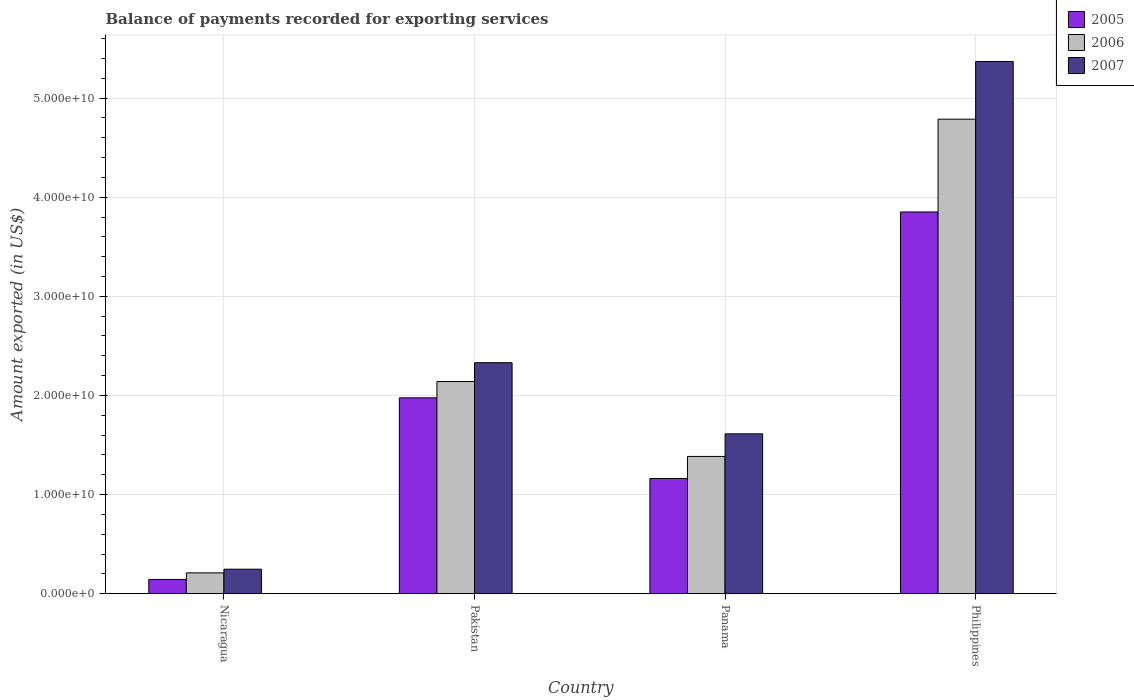Are the number of bars per tick equal to the number of legend labels?
Give a very brief answer. Yes. Are the number of bars on each tick of the X-axis equal?
Offer a very short reply. Yes. How many bars are there on the 2nd tick from the left?
Your answer should be compact. 3. How many bars are there on the 4th tick from the right?
Offer a terse response. 3. What is the label of the 2nd group of bars from the left?
Your answer should be compact. Pakistan. In how many cases, is the number of bars for a given country not equal to the number of legend labels?
Your answer should be very brief. 0. What is the amount exported in 2006 in Panama?
Provide a short and direct response. 1.38e+1. Across all countries, what is the maximum amount exported in 2007?
Keep it short and to the point. 5.37e+1. Across all countries, what is the minimum amount exported in 2007?
Provide a succinct answer. 2.47e+09. In which country was the amount exported in 2005 maximum?
Keep it short and to the point. Philippines. In which country was the amount exported in 2007 minimum?
Offer a very short reply. Nicaragua. What is the total amount exported in 2007 in the graph?
Your answer should be compact. 9.56e+1. What is the difference between the amount exported in 2005 in Nicaragua and that in Philippines?
Ensure brevity in your answer.  -3.71e+1. What is the difference between the amount exported in 2005 in Nicaragua and the amount exported in 2007 in Pakistan?
Your answer should be very brief. -2.19e+1. What is the average amount exported in 2007 per country?
Offer a very short reply. 2.39e+1. What is the difference between the amount exported of/in 2007 and amount exported of/in 2006 in Philippines?
Offer a terse response. 5.82e+09. What is the ratio of the amount exported in 2006 in Nicaragua to that in Pakistan?
Keep it short and to the point. 0.1. Is the amount exported in 2007 in Nicaragua less than that in Pakistan?
Provide a succinct answer. Yes. Is the difference between the amount exported in 2007 in Nicaragua and Philippines greater than the difference between the amount exported in 2006 in Nicaragua and Philippines?
Provide a short and direct response. No. What is the difference between the highest and the second highest amount exported in 2005?
Offer a very short reply. 1.88e+1. What is the difference between the highest and the lowest amount exported in 2005?
Give a very brief answer. 3.71e+1. What does the 2nd bar from the right in Panama represents?
Give a very brief answer. 2006. Is it the case that in every country, the sum of the amount exported in 2006 and amount exported in 2005 is greater than the amount exported in 2007?
Your answer should be very brief. Yes. Does the graph contain grids?
Your answer should be very brief. Yes. Where does the legend appear in the graph?
Your response must be concise. Top right. What is the title of the graph?
Make the answer very short. Balance of payments recorded for exporting services. Does "1975" appear as one of the legend labels in the graph?
Provide a short and direct response. No. What is the label or title of the X-axis?
Your response must be concise. Country. What is the label or title of the Y-axis?
Give a very brief answer. Amount exported (in US$). What is the Amount exported (in US$) of 2005 in Nicaragua?
Make the answer very short. 1.43e+09. What is the Amount exported (in US$) of 2006 in Nicaragua?
Keep it short and to the point. 2.10e+09. What is the Amount exported (in US$) in 2007 in Nicaragua?
Your response must be concise. 2.47e+09. What is the Amount exported (in US$) in 2005 in Pakistan?
Offer a terse response. 1.98e+1. What is the Amount exported (in US$) in 2006 in Pakistan?
Your answer should be very brief. 2.14e+1. What is the Amount exported (in US$) of 2007 in Pakistan?
Your answer should be compact. 2.33e+1. What is the Amount exported (in US$) of 2005 in Panama?
Your answer should be compact. 1.16e+1. What is the Amount exported (in US$) of 2006 in Panama?
Give a very brief answer. 1.38e+1. What is the Amount exported (in US$) in 2007 in Panama?
Your answer should be compact. 1.61e+1. What is the Amount exported (in US$) of 2005 in Philippines?
Keep it short and to the point. 3.85e+1. What is the Amount exported (in US$) in 2006 in Philippines?
Offer a very short reply. 4.79e+1. What is the Amount exported (in US$) of 2007 in Philippines?
Offer a very short reply. 5.37e+1. Across all countries, what is the maximum Amount exported (in US$) of 2005?
Provide a short and direct response. 3.85e+1. Across all countries, what is the maximum Amount exported (in US$) of 2006?
Provide a succinct answer. 4.79e+1. Across all countries, what is the maximum Amount exported (in US$) of 2007?
Offer a very short reply. 5.37e+1. Across all countries, what is the minimum Amount exported (in US$) in 2005?
Offer a terse response. 1.43e+09. Across all countries, what is the minimum Amount exported (in US$) in 2006?
Your response must be concise. 2.10e+09. Across all countries, what is the minimum Amount exported (in US$) of 2007?
Your answer should be very brief. 2.47e+09. What is the total Amount exported (in US$) in 2005 in the graph?
Keep it short and to the point. 7.13e+1. What is the total Amount exported (in US$) in 2006 in the graph?
Provide a short and direct response. 8.52e+1. What is the total Amount exported (in US$) of 2007 in the graph?
Your answer should be compact. 9.56e+1. What is the difference between the Amount exported (in US$) of 2005 in Nicaragua and that in Pakistan?
Make the answer very short. -1.83e+1. What is the difference between the Amount exported (in US$) in 2006 in Nicaragua and that in Pakistan?
Your response must be concise. -1.93e+1. What is the difference between the Amount exported (in US$) of 2007 in Nicaragua and that in Pakistan?
Keep it short and to the point. -2.08e+1. What is the difference between the Amount exported (in US$) in 2005 in Nicaragua and that in Panama?
Give a very brief answer. -1.02e+1. What is the difference between the Amount exported (in US$) in 2006 in Nicaragua and that in Panama?
Your response must be concise. -1.17e+1. What is the difference between the Amount exported (in US$) of 2007 in Nicaragua and that in Panama?
Your answer should be compact. -1.37e+1. What is the difference between the Amount exported (in US$) of 2005 in Nicaragua and that in Philippines?
Make the answer very short. -3.71e+1. What is the difference between the Amount exported (in US$) of 2006 in Nicaragua and that in Philippines?
Make the answer very short. -4.58e+1. What is the difference between the Amount exported (in US$) of 2007 in Nicaragua and that in Philippines?
Your answer should be very brief. -5.12e+1. What is the difference between the Amount exported (in US$) of 2005 in Pakistan and that in Panama?
Your answer should be compact. 8.14e+09. What is the difference between the Amount exported (in US$) in 2006 in Pakistan and that in Panama?
Make the answer very short. 7.56e+09. What is the difference between the Amount exported (in US$) of 2007 in Pakistan and that in Panama?
Your answer should be very brief. 7.18e+09. What is the difference between the Amount exported (in US$) of 2005 in Pakistan and that in Philippines?
Your answer should be compact. -1.88e+1. What is the difference between the Amount exported (in US$) in 2006 in Pakistan and that in Philippines?
Make the answer very short. -2.65e+1. What is the difference between the Amount exported (in US$) in 2007 in Pakistan and that in Philippines?
Offer a terse response. -3.04e+1. What is the difference between the Amount exported (in US$) of 2005 in Panama and that in Philippines?
Your answer should be compact. -2.69e+1. What is the difference between the Amount exported (in US$) in 2006 in Panama and that in Philippines?
Give a very brief answer. -3.40e+1. What is the difference between the Amount exported (in US$) of 2007 in Panama and that in Philippines?
Ensure brevity in your answer.  -3.76e+1. What is the difference between the Amount exported (in US$) of 2005 in Nicaragua and the Amount exported (in US$) of 2006 in Pakistan?
Provide a short and direct response. -2.00e+1. What is the difference between the Amount exported (in US$) of 2005 in Nicaragua and the Amount exported (in US$) of 2007 in Pakistan?
Ensure brevity in your answer.  -2.19e+1. What is the difference between the Amount exported (in US$) of 2006 in Nicaragua and the Amount exported (in US$) of 2007 in Pakistan?
Your answer should be compact. -2.12e+1. What is the difference between the Amount exported (in US$) in 2005 in Nicaragua and the Amount exported (in US$) in 2006 in Panama?
Your answer should be very brief. -1.24e+1. What is the difference between the Amount exported (in US$) of 2005 in Nicaragua and the Amount exported (in US$) of 2007 in Panama?
Your response must be concise. -1.47e+1. What is the difference between the Amount exported (in US$) of 2006 in Nicaragua and the Amount exported (in US$) of 2007 in Panama?
Your answer should be very brief. -1.40e+1. What is the difference between the Amount exported (in US$) of 2005 in Nicaragua and the Amount exported (in US$) of 2006 in Philippines?
Give a very brief answer. -4.64e+1. What is the difference between the Amount exported (in US$) in 2005 in Nicaragua and the Amount exported (in US$) in 2007 in Philippines?
Your answer should be compact. -5.23e+1. What is the difference between the Amount exported (in US$) in 2006 in Nicaragua and the Amount exported (in US$) in 2007 in Philippines?
Your answer should be compact. -5.16e+1. What is the difference between the Amount exported (in US$) of 2005 in Pakistan and the Amount exported (in US$) of 2006 in Panama?
Offer a very short reply. 5.91e+09. What is the difference between the Amount exported (in US$) in 2005 in Pakistan and the Amount exported (in US$) in 2007 in Panama?
Your answer should be very brief. 3.64e+09. What is the difference between the Amount exported (in US$) in 2006 in Pakistan and the Amount exported (in US$) in 2007 in Panama?
Offer a very short reply. 5.28e+09. What is the difference between the Amount exported (in US$) of 2005 in Pakistan and the Amount exported (in US$) of 2006 in Philippines?
Your response must be concise. -2.81e+1. What is the difference between the Amount exported (in US$) in 2005 in Pakistan and the Amount exported (in US$) in 2007 in Philippines?
Your response must be concise. -3.39e+1. What is the difference between the Amount exported (in US$) of 2006 in Pakistan and the Amount exported (in US$) of 2007 in Philippines?
Provide a short and direct response. -3.23e+1. What is the difference between the Amount exported (in US$) of 2005 in Panama and the Amount exported (in US$) of 2006 in Philippines?
Offer a terse response. -3.63e+1. What is the difference between the Amount exported (in US$) of 2005 in Panama and the Amount exported (in US$) of 2007 in Philippines?
Your answer should be very brief. -4.21e+1. What is the difference between the Amount exported (in US$) of 2006 in Panama and the Amount exported (in US$) of 2007 in Philippines?
Offer a very short reply. -3.99e+1. What is the average Amount exported (in US$) of 2005 per country?
Keep it short and to the point. 1.78e+1. What is the average Amount exported (in US$) in 2006 per country?
Your answer should be very brief. 2.13e+1. What is the average Amount exported (in US$) of 2007 per country?
Offer a terse response. 2.39e+1. What is the difference between the Amount exported (in US$) in 2005 and Amount exported (in US$) in 2006 in Nicaragua?
Provide a succinct answer. -6.63e+08. What is the difference between the Amount exported (in US$) in 2005 and Amount exported (in US$) in 2007 in Nicaragua?
Provide a short and direct response. -1.04e+09. What is the difference between the Amount exported (in US$) of 2006 and Amount exported (in US$) of 2007 in Nicaragua?
Provide a short and direct response. -3.72e+08. What is the difference between the Amount exported (in US$) of 2005 and Amount exported (in US$) of 2006 in Pakistan?
Your answer should be very brief. -1.64e+09. What is the difference between the Amount exported (in US$) in 2005 and Amount exported (in US$) in 2007 in Pakistan?
Your answer should be compact. -3.54e+09. What is the difference between the Amount exported (in US$) of 2006 and Amount exported (in US$) of 2007 in Pakistan?
Provide a short and direct response. -1.90e+09. What is the difference between the Amount exported (in US$) in 2005 and Amount exported (in US$) in 2006 in Panama?
Provide a short and direct response. -2.23e+09. What is the difference between the Amount exported (in US$) of 2005 and Amount exported (in US$) of 2007 in Panama?
Provide a short and direct response. -4.51e+09. What is the difference between the Amount exported (in US$) of 2006 and Amount exported (in US$) of 2007 in Panama?
Provide a succinct answer. -2.28e+09. What is the difference between the Amount exported (in US$) in 2005 and Amount exported (in US$) in 2006 in Philippines?
Your answer should be very brief. -9.36e+09. What is the difference between the Amount exported (in US$) in 2005 and Amount exported (in US$) in 2007 in Philippines?
Give a very brief answer. -1.52e+1. What is the difference between the Amount exported (in US$) of 2006 and Amount exported (in US$) of 2007 in Philippines?
Your answer should be very brief. -5.82e+09. What is the ratio of the Amount exported (in US$) of 2005 in Nicaragua to that in Pakistan?
Your answer should be very brief. 0.07. What is the ratio of the Amount exported (in US$) of 2006 in Nicaragua to that in Pakistan?
Make the answer very short. 0.1. What is the ratio of the Amount exported (in US$) of 2007 in Nicaragua to that in Pakistan?
Keep it short and to the point. 0.11. What is the ratio of the Amount exported (in US$) of 2005 in Nicaragua to that in Panama?
Keep it short and to the point. 0.12. What is the ratio of the Amount exported (in US$) of 2006 in Nicaragua to that in Panama?
Provide a short and direct response. 0.15. What is the ratio of the Amount exported (in US$) in 2007 in Nicaragua to that in Panama?
Give a very brief answer. 0.15. What is the ratio of the Amount exported (in US$) of 2005 in Nicaragua to that in Philippines?
Provide a short and direct response. 0.04. What is the ratio of the Amount exported (in US$) in 2006 in Nicaragua to that in Philippines?
Your answer should be very brief. 0.04. What is the ratio of the Amount exported (in US$) of 2007 in Nicaragua to that in Philippines?
Offer a terse response. 0.05. What is the ratio of the Amount exported (in US$) of 2005 in Pakistan to that in Panama?
Offer a terse response. 1.7. What is the ratio of the Amount exported (in US$) in 2006 in Pakistan to that in Panama?
Keep it short and to the point. 1.55. What is the ratio of the Amount exported (in US$) in 2007 in Pakistan to that in Panama?
Your response must be concise. 1.45. What is the ratio of the Amount exported (in US$) of 2005 in Pakistan to that in Philippines?
Provide a succinct answer. 0.51. What is the ratio of the Amount exported (in US$) in 2006 in Pakistan to that in Philippines?
Offer a terse response. 0.45. What is the ratio of the Amount exported (in US$) of 2007 in Pakistan to that in Philippines?
Keep it short and to the point. 0.43. What is the ratio of the Amount exported (in US$) in 2005 in Panama to that in Philippines?
Offer a terse response. 0.3. What is the ratio of the Amount exported (in US$) of 2006 in Panama to that in Philippines?
Your answer should be compact. 0.29. What is the ratio of the Amount exported (in US$) of 2007 in Panama to that in Philippines?
Your response must be concise. 0.3. What is the difference between the highest and the second highest Amount exported (in US$) of 2005?
Ensure brevity in your answer.  1.88e+1. What is the difference between the highest and the second highest Amount exported (in US$) of 2006?
Keep it short and to the point. 2.65e+1. What is the difference between the highest and the second highest Amount exported (in US$) in 2007?
Offer a very short reply. 3.04e+1. What is the difference between the highest and the lowest Amount exported (in US$) of 2005?
Your answer should be compact. 3.71e+1. What is the difference between the highest and the lowest Amount exported (in US$) in 2006?
Your answer should be very brief. 4.58e+1. What is the difference between the highest and the lowest Amount exported (in US$) in 2007?
Keep it short and to the point. 5.12e+1. 